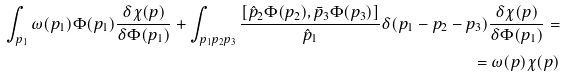Convert formula to latex. <formula><loc_0><loc_0><loc_500><loc_500>\int _ { p _ { 1 } } \omega ( p _ { 1 } ) \Phi ( p _ { 1 } ) \frac { \delta \chi ( p ) } { \delta \Phi ( p _ { 1 } ) } + \int _ { p _ { 1 } p _ { 2 } p _ { 3 } } \frac { \left [ \hat { p } _ { 2 } \Phi ( p _ { 2 } ) , \bar { p } _ { 3 } \Phi ( p _ { 3 } ) \right ] } { \hat { p } _ { 1 } } \delta ( p _ { 1 } - p _ { 2 } - p _ { 3 } ) \frac { \delta \chi ( p ) } { \delta \Phi ( p _ { 1 } ) } = \\ = \omega ( p ) \chi ( p )</formula> 